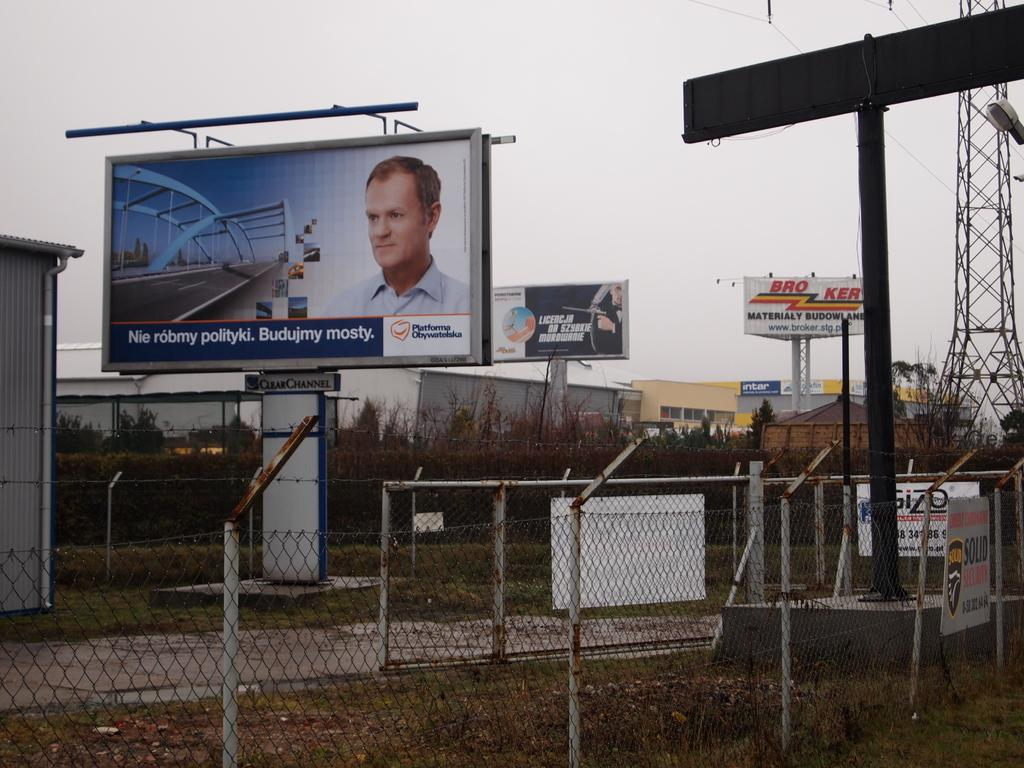<image>
Describe the image concisely. Several foreign language billboards are standing behind a chain link fence. 